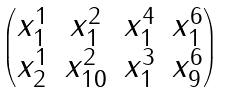Convert formula to latex. <formula><loc_0><loc_0><loc_500><loc_500>\begin{pmatrix} x _ { 1 } ^ { 1 } & x _ { 1 } ^ { 2 } & x _ { 1 } ^ { 4 } & x _ { 1 } ^ { 6 } \\ x _ { 2 } ^ { 1 } & x _ { 1 0 } ^ { 2 } & x _ { 1 } ^ { 3 } & x _ { 9 } ^ { 6 } \end{pmatrix}</formula> 